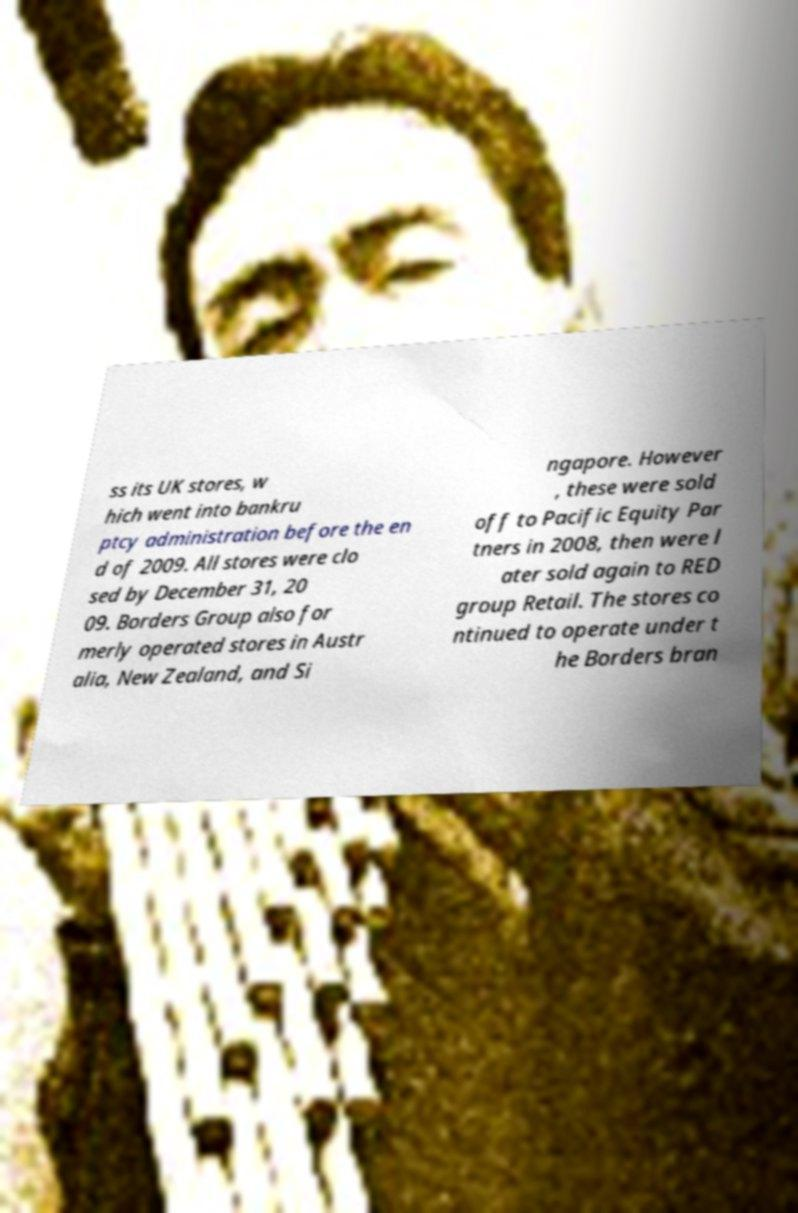I need the written content from this picture converted into text. Can you do that? ss its UK stores, w hich went into bankru ptcy administration before the en d of 2009. All stores were clo sed by December 31, 20 09. Borders Group also for merly operated stores in Austr alia, New Zealand, and Si ngapore. However , these were sold off to Pacific Equity Par tners in 2008, then were l ater sold again to RED group Retail. The stores co ntinued to operate under t he Borders bran 